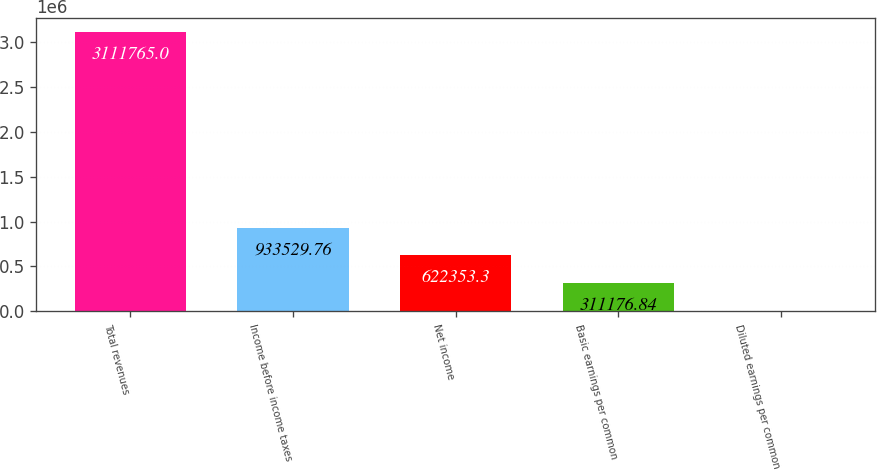<chart> <loc_0><loc_0><loc_500><loc_500><bar_chart><fcel>Total revenues<fcel>Income before income taxes<fcel>Net income<fcel>Basic earnings per common<fcel>Diluted earnings per common<nl><fcel>3.11176e+06<fcel>933530<fcel>622353<fcel>311177<fcel>0.38<nl></chart> 